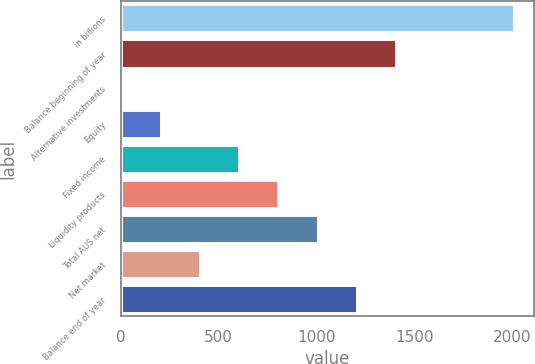Convert chart. <chart><loc_0><loc_0><loc_500><loc_500><bar_chart><fcel>in billions<fcel>Balance beginning of year<fcel>Alternative investments<fcel>Equity<fcel>Fixed income<fcel>Liquidity products<fcel>Total AUS net<fcel>Net market<fcel>Balance end of year<nl><fcel>2011<fcel>1408<fcel>1<fcel>202<fcel>604<fcel>805<fcel>1006<fcel>403<fcel>1207<nl></chart> 